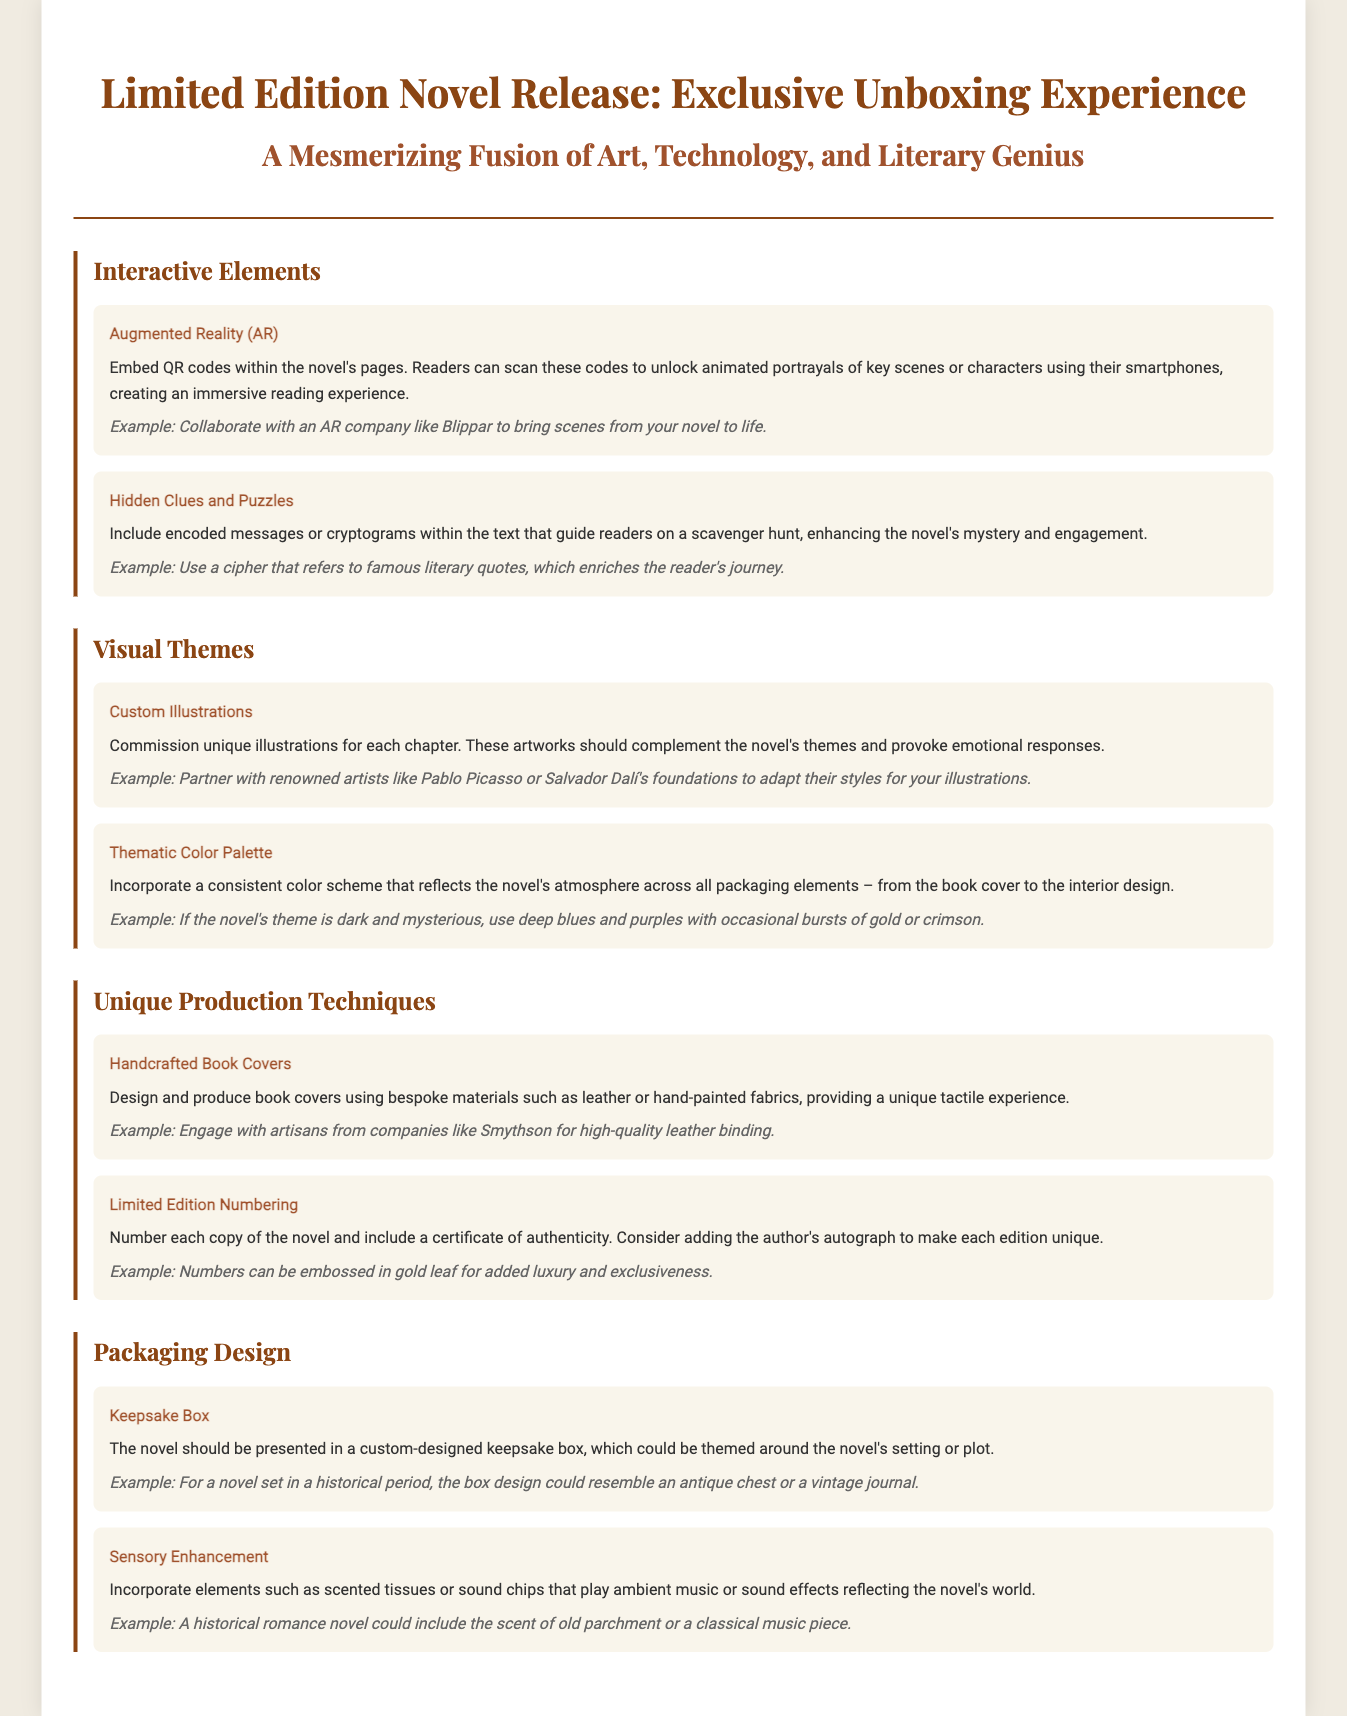What is the title of the novel release? The title of the novel release is presented prominently in the document's header.
Answer: Limited Edition Novel Release: Exclusive Unboxing Experience What type of interactive element is included? The document describes various interactive elements aimed at enhancing reader engagement, one of which is notable.
Answer: Augmented Reality (AR) Who can be partnered with for custom illustrations? The document mentions renowned artists that could be engaged for illustrations.
Answer: Pablo Picasso or Salvador Dalí's foundations What is used for the handcrafted book covers? The document specifies materials intended for the unique production of book covers.
Answer: Leather or hand-painted fabrics What element enhances the sensory experience? The document details a specific sensory enhancement feature included in the packaging design.
Answer: Scented tissues or sound chips What does the limited edition numbering include? The document describes what is included along with the numbering of each copy.
Answer: A certificate of authenticity What should be themed around the novel's setting? The document suggests a design characteristic related to the keepsake box.
Answer: Custom-designed keepsake box What is the aim of including hidden clues and puzzles? The document outlines a specific purpose of these interactive elements within the reading experience.
Answer: Enhancing the novel's mystery and engagement How many sections are there in the document? The document includes various distinct sections, each covering a different aspect of the unboxing experience.
Answer: Four sections 